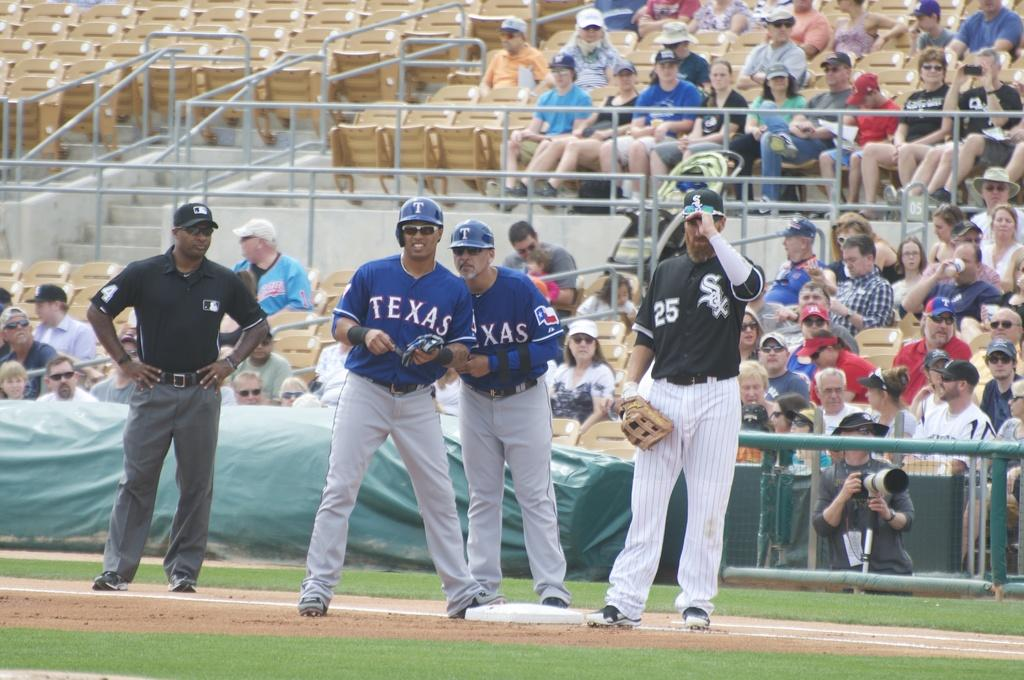<image>
Write a terse but informative summary of the picture. A baseball player wearing a Texas jersey is currently standing on a base 